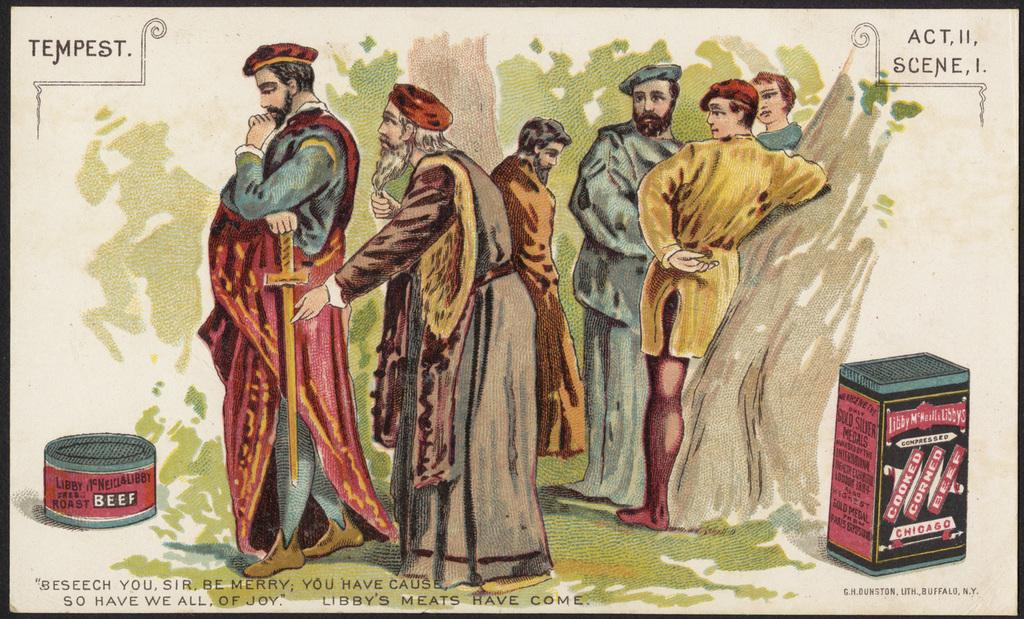What is present in the image? There is a poster in the image. What is depicted on the poster? The poster contains a drawing of people standing. What can be seen in the background of the drawing? There are trees visible in the drawing. How many boxes are present in the drawing? There are 2 boxes in the drawing. What is written at the bottom of the drawing? There is some matter written at the bottom of the drawing. What type of jellyfish can be seen swimming in the drawing? There are no jellyfish present in the drawing; it features people standing, trees, and boxes. Is the drawing a map of a specific location? The drawing is not a map; it is a drawing of people standing with trees and boxes in the background. 